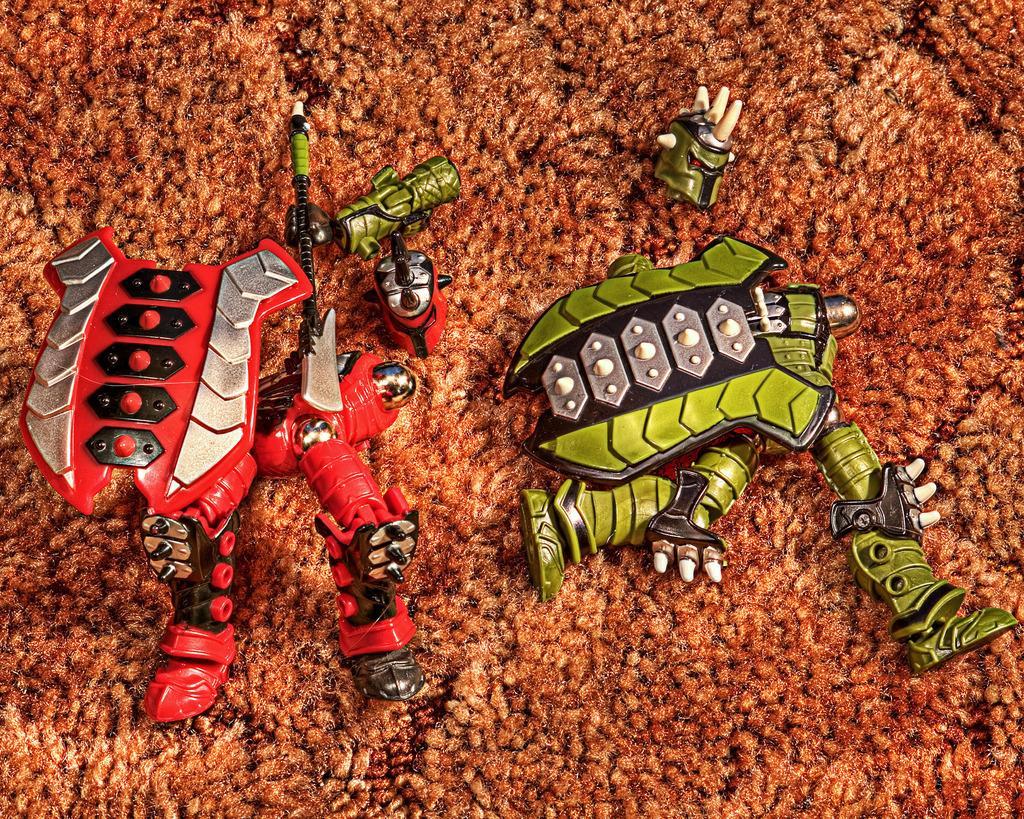Could you give a brief overview of what you see in this image? In this image we can see toys on a brown color surface. 